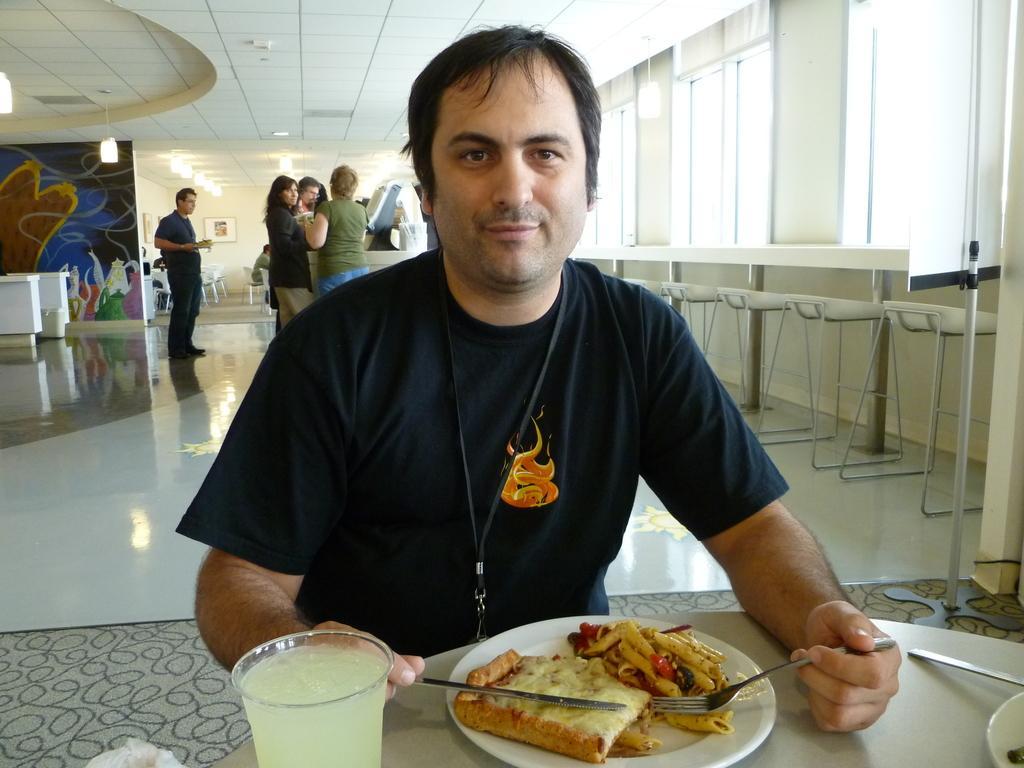Can you describe this image briefly? In this image I can see the person with the black color. In-front of the person I can see plate with food, glass and one more plate on the table. I can see the person holding the fork and knife. In the background I can see the group of people, machines, chairs and I can see the boards to the wall. I can see the lights at the top. To the right I can see the window blinds. 